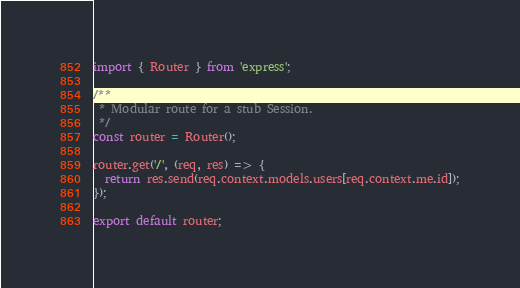Convert code to text. <code><loc_0><loc_0><loc_500><loc_500><_JavaScript_>import { Router } from 'express';

/**
 * Modular route for a stub Session.
 */
const router = Router();

router.get('/', (req, res) => {
  return res.send(req.context.models.users[req.context.me.id]);
});

export default router;
</code> 